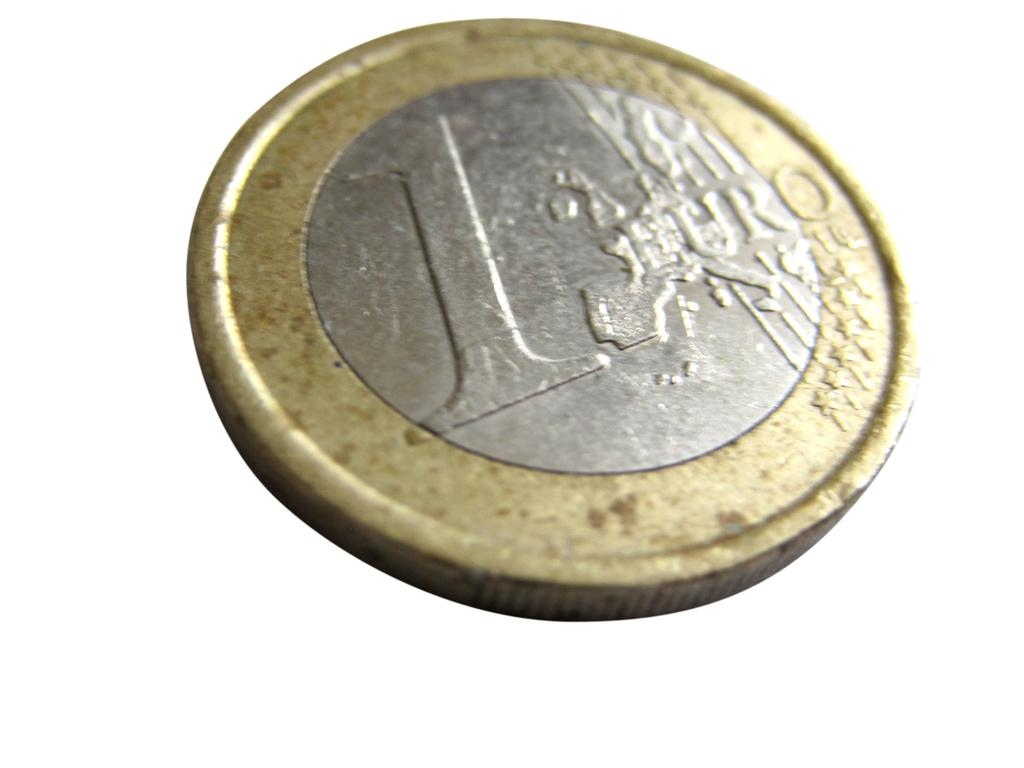<image>
Summarize the visual content of the image. A gold and silver coin with a number one and the word euro on it. 